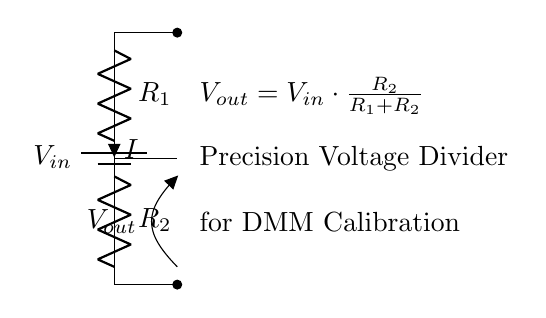What are the two resistors in the voltage divider? The circuit diagram labels the two precision resistors as R1 and R2, which are essential components of the voltage divider network.
Answer: R1, R2 What is the formula for the output voltage? The diagram provides the equation for the output voltage as Vout = Vin * (R2 / (R1 + R2)), indicating how the output voltage relates to the input voltage and the resistors.
Answer: Vout = Vin * (R2 / (R1 + R2)) What is the role of the voltage divider? The voltage divider is designated for calibrating digital multimeters, as indicated in the circuit labels, providing a specific output voltage for measurement purposes.
Answer: Calibrating DMM What happens to the output voltage if R1 is much larger than R2? If R1 is much larger than R2, then the output voltage Vout approaches zero, as the ratio R2 / (R1 + R2) becomes very small.
Answer: Approaches zero What does the output voltage depend on? The output voltage Vout depends on both the input voltage Vin and the values of the resistors R1 and R2, as shown in the voltage divider formula.
Answer: R1, R2, Vin What type of circuit is this? This circuit is classified as a voltage divider, which is used to produce a specific voltage from a higher voltage source using resistors.
Answer: Voltage divider What do the nodes in the diagram represent? The nodes in the circuit diagram represent connection points where the battery, resistors, and the output voltage are interconnected, facilitating the flow of current and voltage division.
Answer: Connection points 